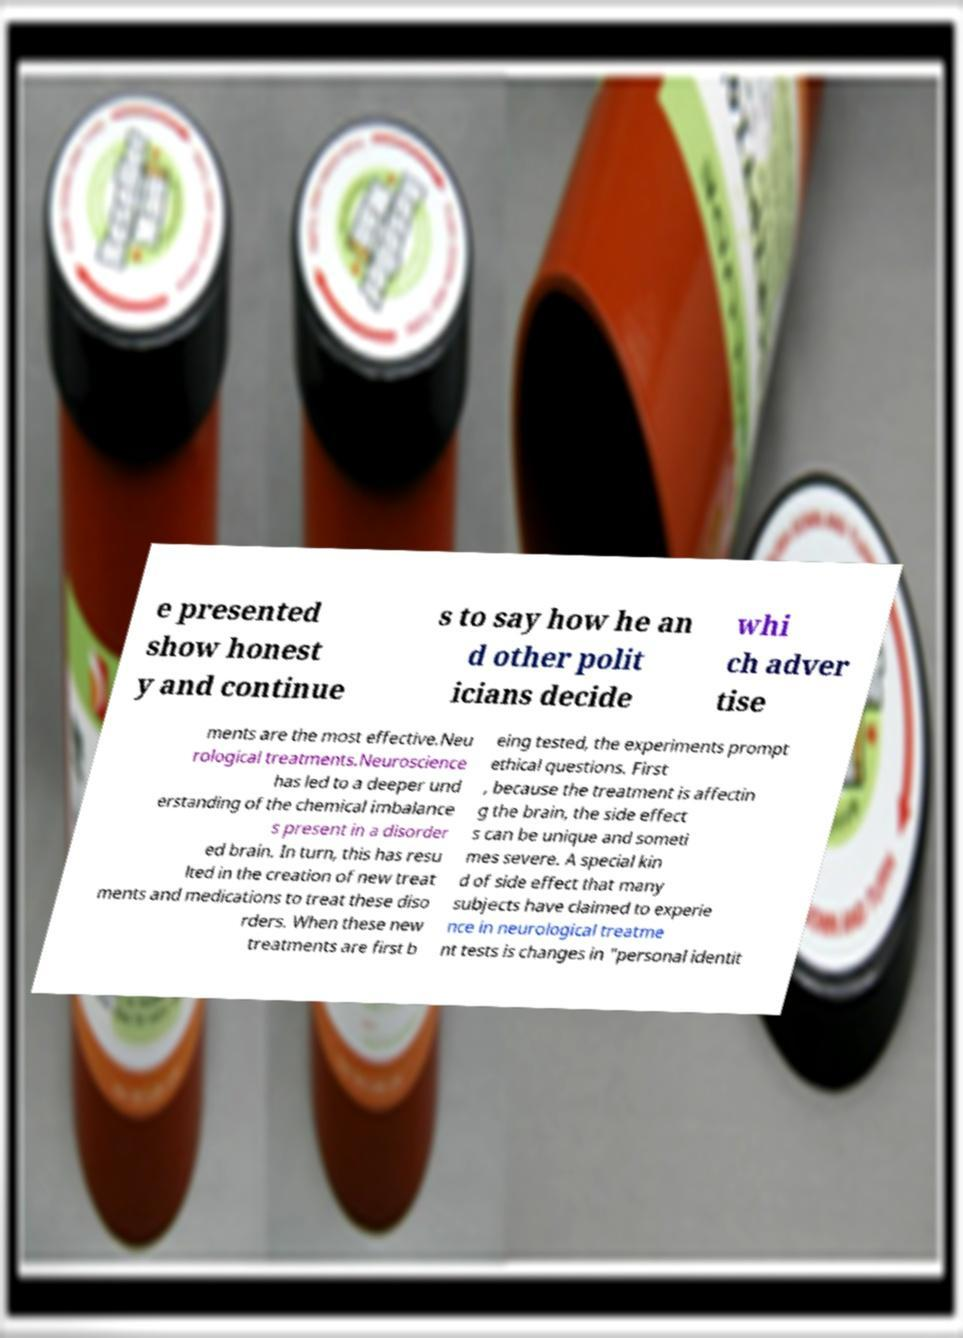Please read and relay the text visible in this image. What does it say? e presented show honest y and continue s to say how he an d other polit icians decide whi ch adver tise ments are the most effective.Neu rological treatments.Neuroscience has led to a deeper und erstanding of the chemical imbalance s present in a disorder ed brain. In turn, this has resu lted in the creation of new treat ments and medications to treat these diso rders. When these new treatments are first b eing tested, the experiments prompt ethical questions. First , because the treatment is affectin g the brain, the side effect s can be unique and someti mes severe. A special kin d of side effect that many subjects have claimed to experie nce in neurological treatme nt tests is changes in "personal identit 